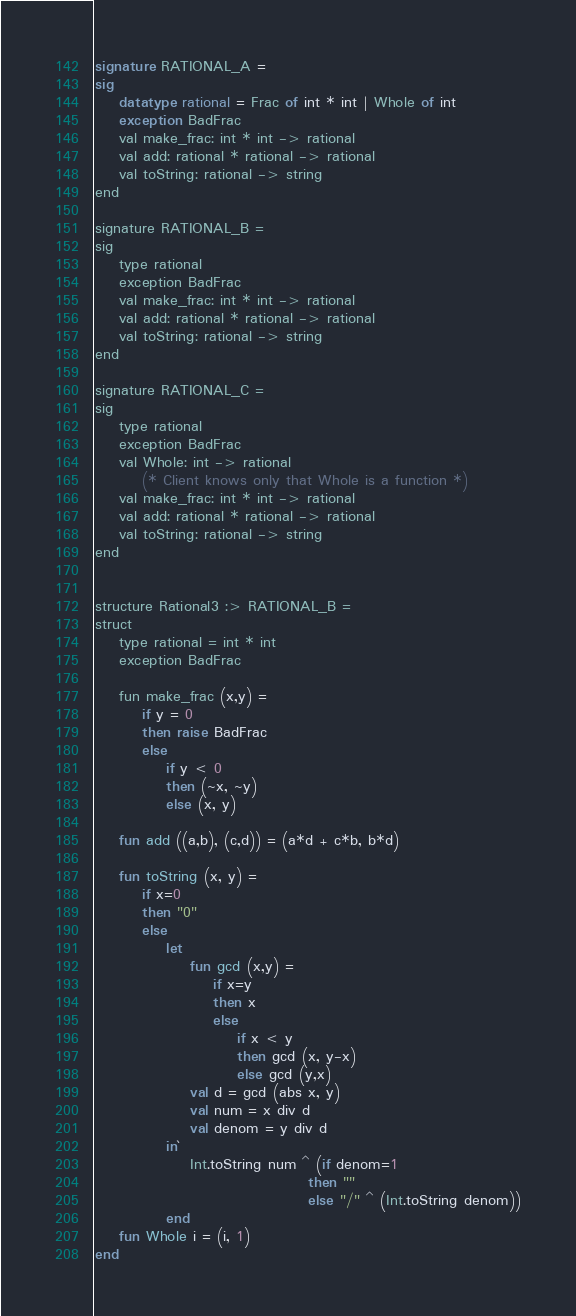Convert code to text. <code><loc_0><loc_0><loc_500><loc_500><_SML_>
signature RATIONAL_A =
sig
    datatype rational = Frac of int * int | Whole of int
    exception BadFrac
    val make_frac: int * int -> rational
    val add: rational * rational -> rational
    val toString: rational -> string
end

signature RATIONAL_B =
sig
    type rational
    exception BadFrac
    val make_frac: int * int -> rational
    val add: rational * rational -> rational
    val toString: rational -> string
end

signature RATIONAL_C =
sig
    type rational
    exception BadFrac
    val Whole: int -> rational
        (* Client knows only that Whole is a function *)
    val make_frac: int * int -> rational
    val add: rational * rational -> rational
    val toString: rational -> string
end


structure Rational3 :> RATIONAL_B =
struct
    type rational = int * int
    exception BadFrac

    fun make_frac (x,y) =
        if y = 0
        then raise BadFrac
        else 
            if y < 0
            then (~x, ~y)
            else (x, y)

    fun add ((a,b), (c,d)) = (a*d + c*b, b*d)

    fun toString (x, y) =
        if x=0
        then "0"
        else
            let
                fun gcd (x,y) =
                    if x=y
                    then x
                    else 
                        if x < y
                        then gcd (x, y-x)
                        else gcd (y,x)
                val d = gcd (abs x, y)
                val num = x div d
                val denom = y div d
            in`
                Int.toString num ^ (if denom=1
                                    then ""
                                    else "/" ^ (Int.toString denom))
            end
    fun Whole i = (i, 1)
end</code> 